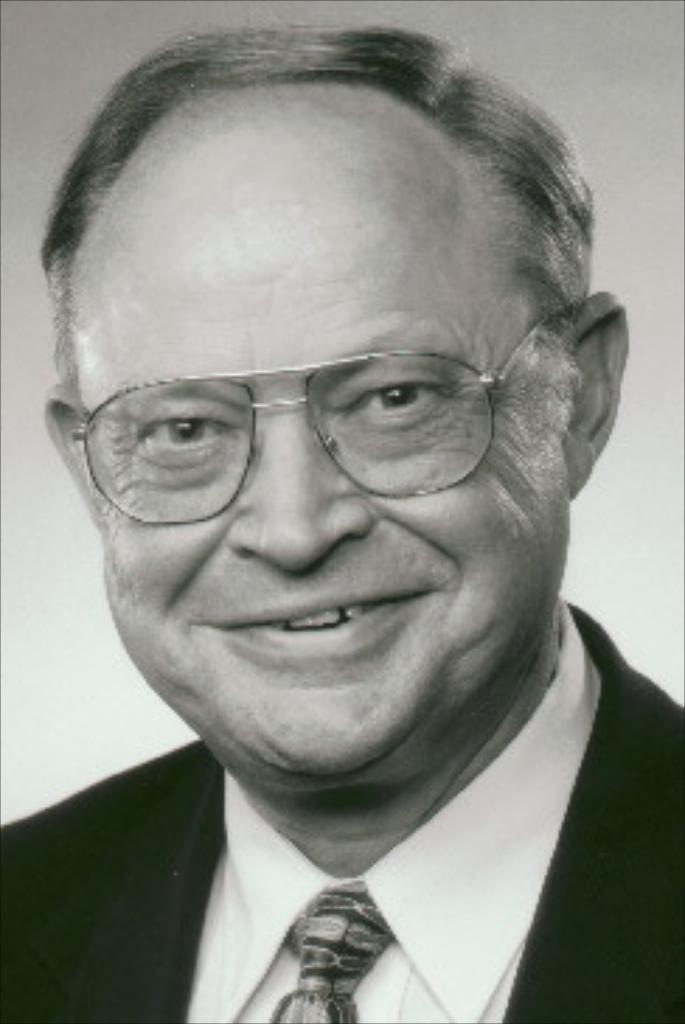Describe this image in one or two sentences. This is a black and white image. In this image we can see a man wearing specs. 